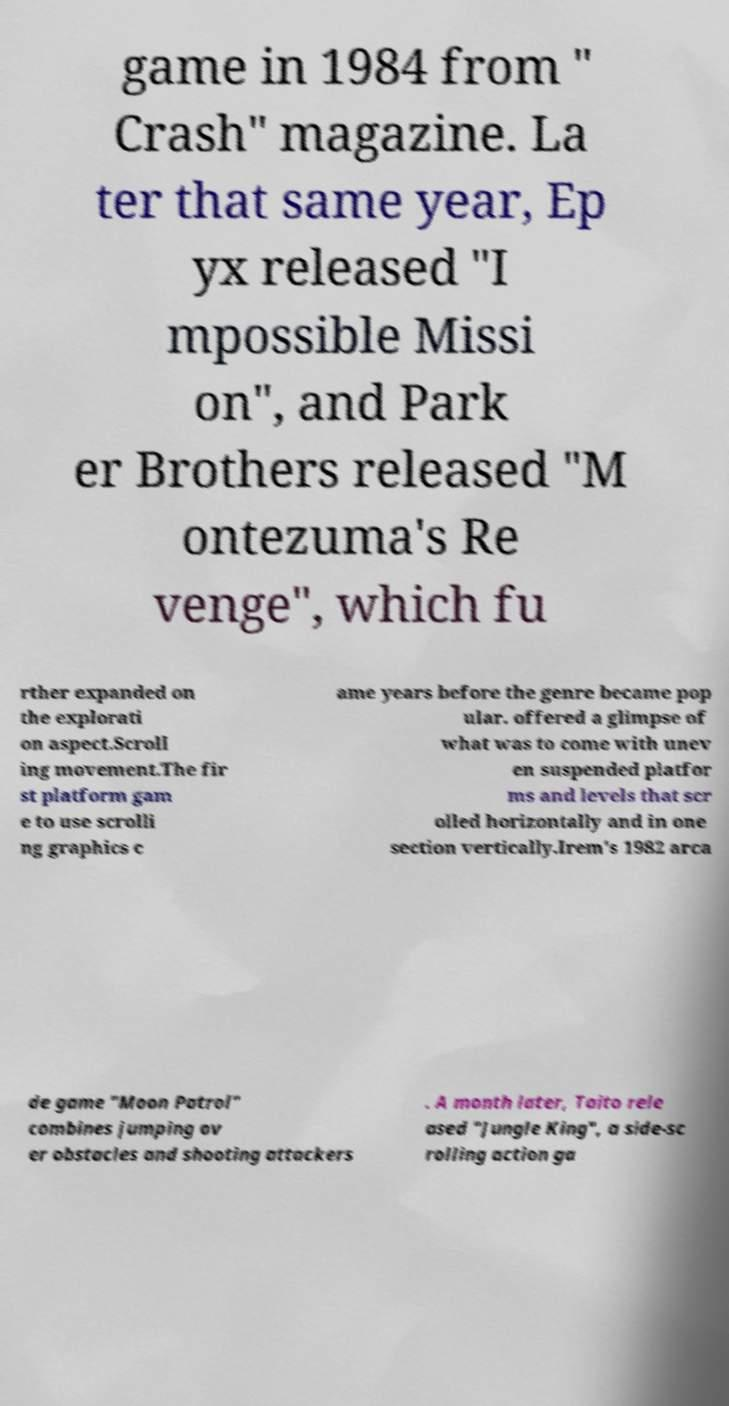Can you read and provide the text displayed in the image?This photo seems to have some interesting text. Can you extract and type it out for me? game in 1984 from " Crash" magazine. La ter that same year, Ep yx released "I mpossible Missi on", and Park er Brothers released "M ontezuma's Re venge", which fu rther expanded on the explorati on aspect.Scroll ing movement.The fir st platform gam e to use scrolli ng graphics c ame years before the genre became pop ular. offered a glimpse of what was to come with unev en suspended platfor ms and levels that scr olled horizontally and in one section vertically.Irem's 1982 arca de game "Moon Patrol" combines jumping ov er obstacles and shooting attackers . A month later, Taito rele ased "Jungle King", a side-sc rolling action ga 